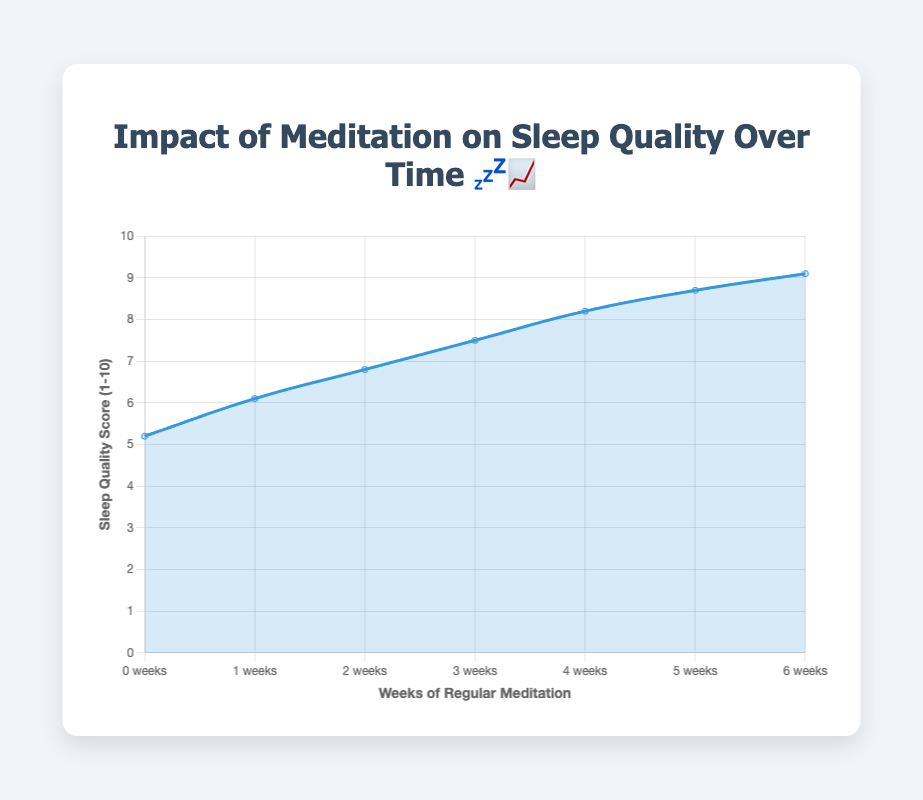What is the title of the chart? The title is clearly displayed at the top of the chart, and it reads "Impact of Meditation on Sleep Quality Over Time 💤📈".
Answer: Impact of Meditation on Sleep Quality Over Time 💤📈 How many weeks of data are shown in the chart? The x-axis labels show the time period in weeks, which goes from 0 to 12.
Answer: 7 weeks What's the sleep quality score at week 0? Locate the data point at week 0 on the x-axis and trace it upwards to find the corresponding y-axis value. The sleep quality score is 5.2.
Answer: 5.2 At which week does the sleep quality score first reach 8? Look at the y-axis for the number 8 and trace it horizontally until it intersects a data point. Then trace that data point down to the x-axis to find the corresponding week. The score first reaches 8 at week 8.
Answer: Week 8 How does the sleep quality score change from week 0 to week 2? Compare the sleep quality scores at week 0 (5.2) and week 2 (6.1). Calculate the difference: 6.1 - 5.2 = 0.9.
Answer: Increases by 0.9 Which week has the highest sleep quality score, and what is the score? Find the highest point on the chart which corresponds to the highest value on the y-axis. The highest score is at week 12, and the score is 9.1.
Answer: Week 12, Score: 9.1 What is the average sleep quality score from week 0 to week 12? Add all the sleep quality scores (5.2, 6.1, 6.8, 7.5, 8.2, 8.7, 9.1) and divide by the number of weeks (7). (5.2 + 6.1 + 6.8 + 7.5 + 8.2 + 8.7 + 9.1) / 7 ≈ 7.37.
Answer: ~7.37 How much did the sleep quality score improve from the start to the end of the period? Calculate the difference between the sleep quality score at week 0 (5.2) and week 12 (9.1). 9.1 - 5.2 = 3.9.
Answer: Improved by 3.9 What emoji is associated with a sleep quality score of 7.5? Identify the score on the y-axis, look at the corresponding data point in the chart, and check the provided dataset to find the emoji for that score, which is 🌙.
Answer: 🌙 Which weeks show a consistent increase in sleep quality scores? Observe the trend line and note the weeks with an increasing slope. The scores consistently increase from week 0 to week 12.
Answer: Weeks 0 to 12 